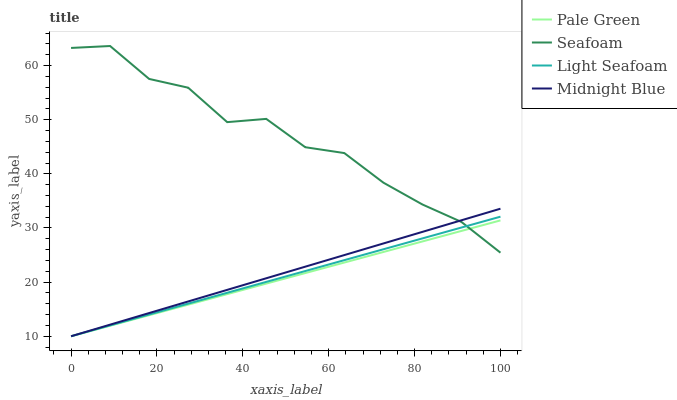Does Pale Green have the minimum area under the curve?
Answer yes or no. Yes. Does Seafoam have the maximum area under the curve?
Answer yes or no. Yes. Does Light Seafoam have the minimum area under the curve?
Answer yes or no. No. Does Light Seafoam have the maximum area under the curve?
Answer yes or no. No. Is Pale Green the smoothest?
Answer yes or no. Yes. Is Seafoam the roughest?
Answer yes or no. Yes. Is Light Seafoam the smoothest?
Answer yes or no. No. Is Light Seafoam the roughest?
Answer yes or no. No. Does Pale Green have the lowest value?
Answer yes or no. Yes. Does Seafoam have the lowest value?
Answer yes or no. No. Does Seafoam have the highest value?
Answer yes or no. Yes. Does Light Seafoam have the highest value?
Answer yes or no. No. Does Midnight Blue intersect Light Seafoam?
Answer yes or no. Yes. Is Midnight Blue less than Light Seafoam?
Answer yes or no. No. Is Midnight Blue greater than Light Seafoam?
Answer yes or no. No. 